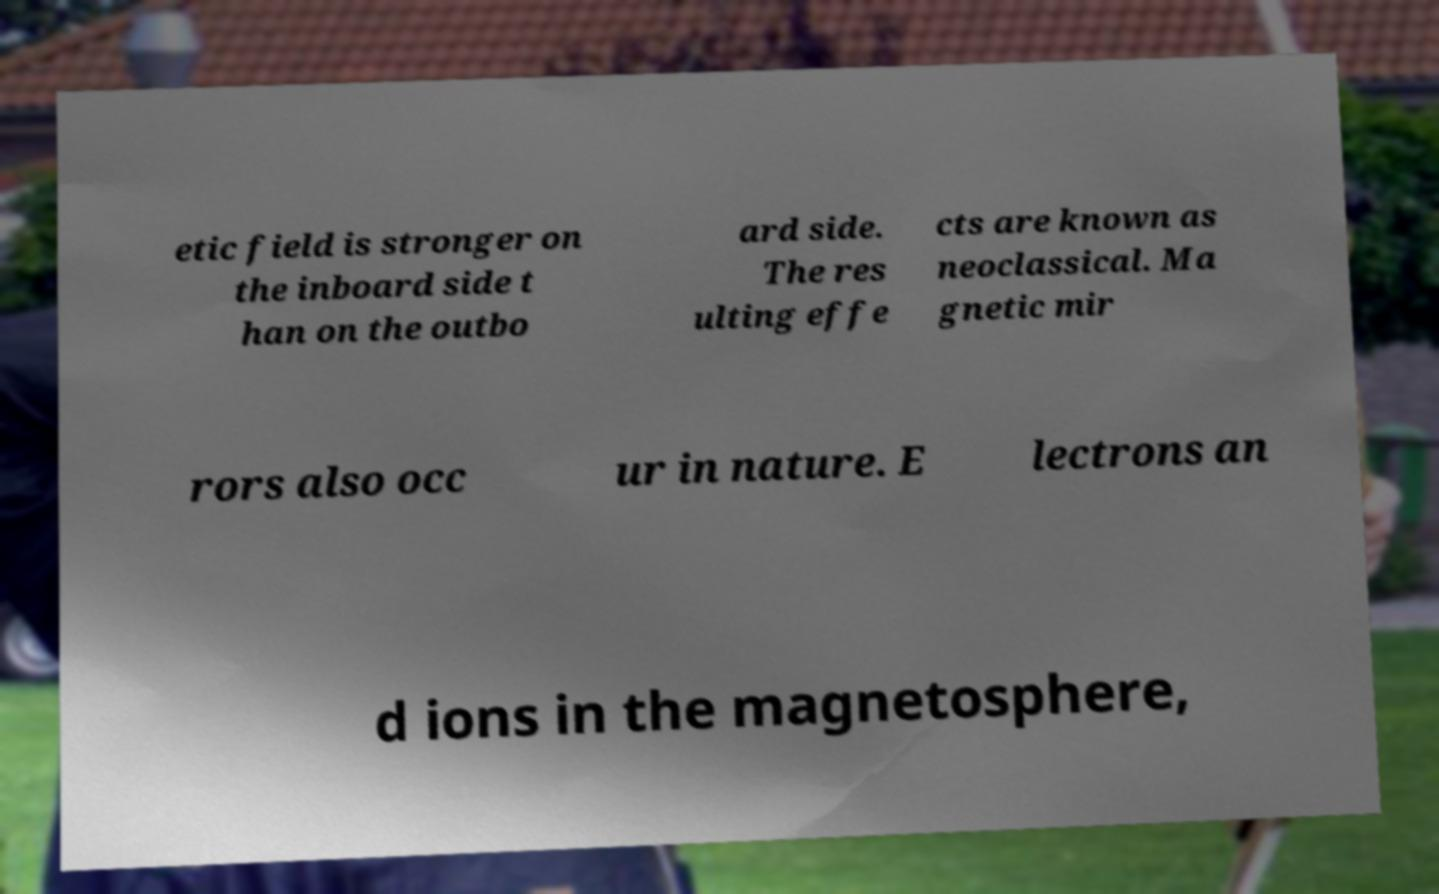Please identify and transcribe the text found in this image. etic field is stronger on the inboard side t han on the outbo ard side. The res ulting effe cts are known as neoclassical. Ma gnetic mir rors also occ ur in nature. E lectrons an d ions in the magnetosphere, 